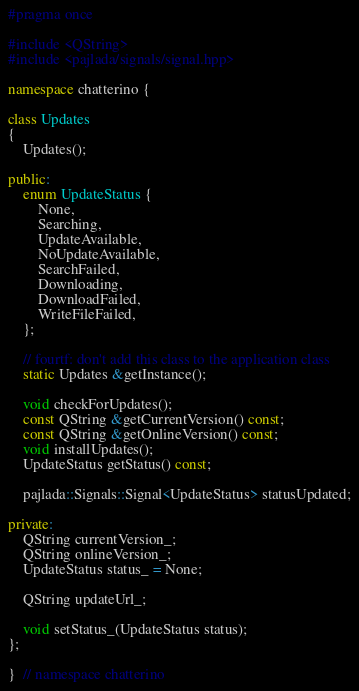Convert code to text. <code><loc_0><loc_0><loc_500><loc_500><_C++_>#pragma once

#include <QString>
#include <pajlada/signals/signal.hpp>

namespace chatterino {

class Updates
{
    Updates();

public:
    enum UpdateStatus {
        None,
        Searching,
        UpdateAvailable,
        NoUpdateAvailable,
        SearchFailed,
        Downloading,
        DownloadFailed,
        WriteFileFailed,
    };

    // fourtf: don't add this class to the application class
    static Updates &getInstance();

    void checkForUpdates();
    const QString &getCurrentVersion() const;
    const QString &getOnlineVersion() const;
    void installUpdates();
    UpdateStatus getStatus() const;

    pajlada::Signals::Signal<UpdateStatus> statusUpdated;

private:
    QString currentVersion_;
    QString onlineVersion_;
    UpdateStatus status_ = None;

    QString updateUrl_;

    void setStatus_(UpdateStatus status);
};

}  // namespace chatterino
</code> 